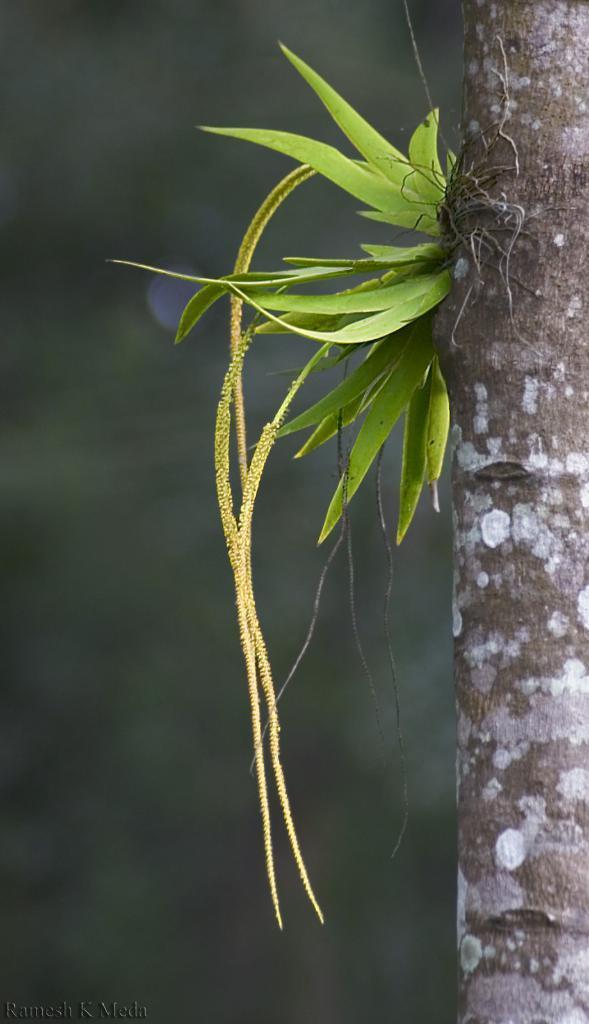How would you summarize this image in a sentence or two? In this image there is a plant to the trunk , and there is blur background. 